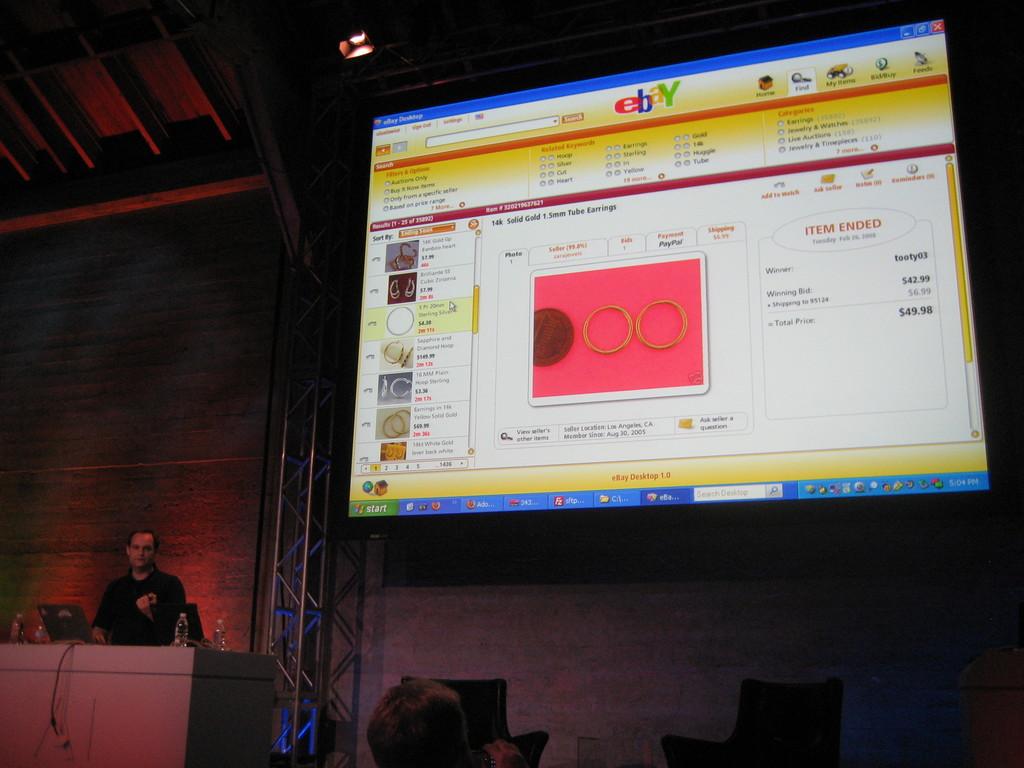What does the multi-colored text at the top say?
Offer a very short reply. Ebay. What does the button at the bottom left of the screen say?
Your response must be concise. Start. 